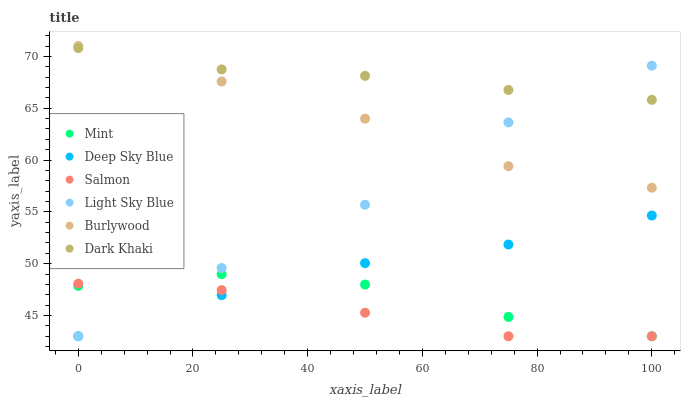Does Salmon have the minimum area under the curve?
Answer yes or no. Yes. Does Dark Khaki have the maximum area under the curve?
Answer yes or no. Yes. Does Dark Khaki have the minimum area under the curve?
Answer yes or no. No. Does Salmon have the maximum area under the curve?
Answer yes or no. No. Is Dark Khaki the smoothest?
Answer yes or no. Yes. Is Mint the roughest?
Answer yes or no. Yes. Is Salmon the smoothest?
Answer yes or no. No. Is Salmon the roughest?
Answer yes or no. No. Does Salmon have the lowest value?
Answer yes or no. Yes. Does Dark Khaki have the lowest value?
Answer yes or no. No. Does Burlywood have the highest value?
Answer yes or no. Yes. Does Dark Khaki have the highest value?
Answer yes or no. No. Is Salmon less than Burlywood?
Answer yes or no. Yes. Is Burlywood greater than Mint?
Answer yes or no. Yes. Does Burlywood intersect Dark Khaki?
Answer yes or no. Yes. Is Burlywood less than Dark Khaki?
Answer yes or no. No. Is Burlywood greater than Dark Khaki?
Answer yes or no. No. Does Salmon intersect Burlywood?
Answer yes or no. No. 